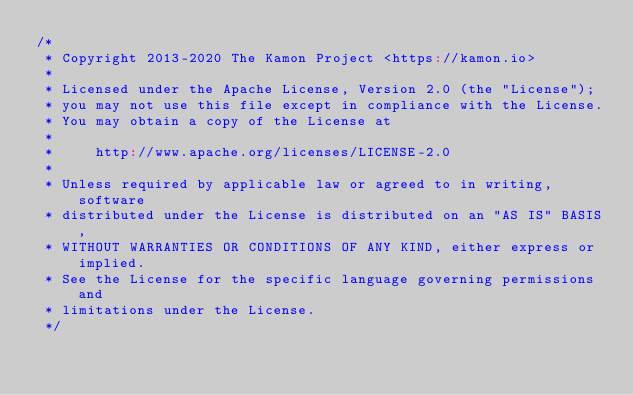<code> <loc_0><loc_0><loc_500><loc_500><_Scala_>/*
 * Copyright 2013-2020 The Kamon Project <https://kamon.io>
 *
 * Licensed under the Apache License, Version 2.0 (the "License");
 * you may not use this file except in compliance with the License.
 * You may obtain a copy of the License at
 *
 *     http://www.apache.org/licenses/LICENSE-2.0
 *
 * Unless required by applicable law or agreed to in writing, software
 * distributed under the License is distributed on an "AS IS" BASIS,
 * WITHOUT WARRANTIES OR CONDITIONS OF ANY KIND, either express or implied.
 * See the License for the specific language governing permissions and
 * limitations under the License.
 */
</code> 